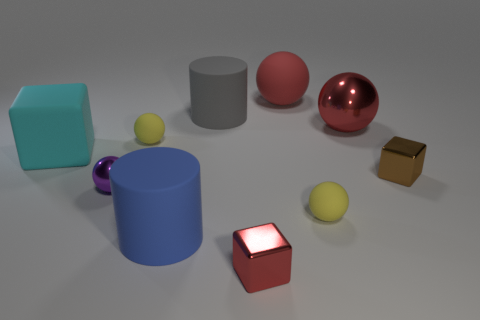Subtract all blue cubes. How many red spheres are left? 2 Subtract all purple balls. How many balls are left? 4 Subtract 3 balls. How many balls are left? 2 Subtract all large matte balls. How many balls are left? 4 Subtract all gray spheres. Subtract all yellow cylinders. How many spheres are left? 5 Subtract all cylinders. How many objects are left? 8 Subtract 1 red cubes. How many objects are left? 9 Subtract all big green shiny things. Subtract all red metal spheres. How many objects are left? 9 Add 1 large cubes. How many large cubes are left? 2 Add 4 yellow spheres. How many yellow spheres exist? 6 